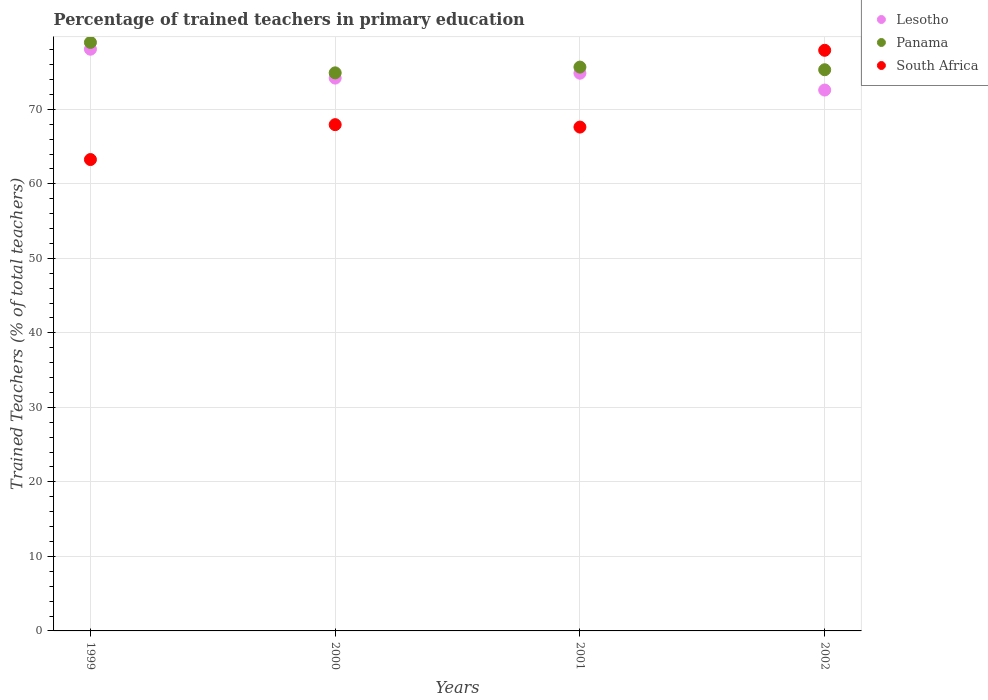What is the percentage of trained teachers in Lesotho in 2000?
Make the answer very short. 74.19. Across all years, what is the maximum percentage of trained teachers in South Africa?
Keep it short and to the point. 77.92. Across all years, what is the minimum percentage of trained teachers in Panama?
Keep it short and to the point. 74.89. In which year was the percentage of trained teachers in Panama maximum?
Offer a very short reply. 1999. In which year was the percentage of trained teachers in Lesotho minimum?
Give a very brief answer. 2002. What is the total percentage of trained teachers in Lesotho in the graph?
Your answer should be very brief. 299.69. What is the difference between the percentage of trained teachers in Lesotho in 2000 and that in 2001?
Your answer should be compact. -0.66. What is the difference between the percentage of trained teachers in South Africa in 2002 and the percentage of trained teachers in Panama in 2000?
Offer a terse response. 3.03. What is the average percentage of trained teachers in Lesotho per year?
Ensure brevity in your answer.  74.92. In the year 2000, what is the difference between the percentage of trained teachers in Lesotho and percentage of trained teachers in Panama?
Offer a very short reply. -0.7. What is the ratio of the percentage of trained teachers in Lesotho in 2001 to that in 2002?
Ensure brevity in your answer.  1.03. What is the difference between the highest and the second highest percentage of trained teachers in South Africa?
Your answer should be compact. 9.98. What is the difference between the highest and the lowest percentage of trained teachers in Lesotho?
Your answer should be very brief. 5.48. In how many years, is the percentage of trained teachers in Lesotho greater than the average percentage of trained teachers in Lesotho taken over all years?
Offer a very short reply. 1. Does the percentage of trained teachers in Panama monotonically increase over the years?
Make the answer very short. No. Is the percentage of trained teachers in Lesotho strictly greater than the percentage of trained teachers in Panama over the years?
Your answer should be compact. No. Is the percentage of trained teachers in South Africa strictly less than the percentage of trained teachers in Panama over the years?
Your answer should be very brief. No. How many years are there in the graph?
Offer a terse response. 4. What is the difference between two consecutive major ticks on the Y-axis?
Your answer should be compact. 10. Does the graph contain any zero values?
Offer a terse response. No. What is the title of the graph?
Your answer should be compact. Percentage of trained teachers in primary education. Does "Italy" appear as one of the legend labels in the graph?
Offer a very short reply. No. What is the label or title of the X-axis?
Offer a very short reply. Years. What is the label or title of the Y-axis?
Offer a very short reply. Trained Teachers (% of total teachers). What is the Trained Teachers (% of total teachers) of Lesotho in 1999?
Give a very brief answer. 78.07. What is the Trained Teachers (% of total teachers) of Panama in 1999?
Your answer should be compact. 78.98. What is the Trained Teachers (% of total teachers) of South Africa in 1999?
Your answer should be very brief. 63.26. What is the Trained Teachers (% of total teachers) of Lesotho in 2000?
Provide a succinct answer. 74.19. What is the Trained Teachers (% of total teachers) in Panama in 2000?
Your response must be concise. 74.89. What is the Trained Teachers (% of total teachers) of South Africa in 2000?
Make the answer very short. 67.94. What is the Trained Teachers (% of total teachers) of Lesotho in 2001?
Make the answer very short. 74.85. What is the Trained Teachers (% of total teachers) of Panama in 2001?
Give a very brief answer. 75.67. What is the Trained Teachers (% of total teachers) of South Africa in 2001?
Give a very brief answer. 67.62. What is the Trained Teachers (% of total teachers) of Lesotho in 2002?
Keep it short and to the point. 72.59. What is the Trained Teachers (% of total teachers) of Panama in 2002?
Ensure brevity in your answer.  75.31. What is the Trained Teachers (% of total teachers) in South Africa in 2002?
Provide a succinct answer. 77.92. Across all years, what is the maximum Trained Teachers (% of total teachers) in Lesotho?
Provide a short and direct response. 78.07. Across all years, what is the maximum Trained Teachers (% of total teachers) of Panama?
Provide a short and direct response. 78.98. Across all years, what is the maximum Trained Teachers (% of total teachers) of South Africa?
Offer a very short reply. 77.92. Across all years, what is the minimum Trained Teachers (% of total teachers) of Lesotho?
Offer a very short reply. 72.59. Across all years, what is the minimum Trained Teachers (% of total teachers) in Panama?
Your response must be concise. 74.89. Across all years, what is the minimum Trained Teachers (% of total teachers) of South Africa?
Keep it short and to the point. 63.26. What is the total Trained Teachers (% of total teachers) of Lesotho in the graph?
Keep it short and to the point. 299.69. What is the total Trained Teachers (% of total teachers) in Panama in the graph?
Make the answer very short. 304.85. What is the total Trained Teachers (% of total teachers) of South Africa in the graph?
Offer a very short reply. 276.74. What is the difference between the Trained Teachers (% of total teachers) in Lesotho in 1999 and that in 2000?
Offer a terse response. 3.88. What is the difference between the Trained Teachers (% of total teachers) of Panama in 1999 and that in 2000?
Offer a terse response. 4.08. What is the difference between the Trained Teachers (% of total teachers) of South Africa in 1999 and that in 2000?
Give a very brief answer. -4.68. What is the difference between the Trained Teachers (% of total teachers) of Lesotho in 1999 and that in 2001?
Ensure brevity in your answer.  3.22. What is the difference between the Trained Teachers (% of total teachers) of Panama in 1999 and that in 2001?
Ensure brevity in your answer.  3.31. What is the difference between the Trained Teachers (% of total teachers) in South Africa in 1999 and that in 2001?
Make the answer very short. -4.36. What is the difference between the Trained Teachers (% of total teachers) in Lesotho in 1999 and that in 2002?
Keep it short and to the point. 5.48. What is the difference between the Trained Teachers (% of total teachers) in Panama in 1999 and that in 2002?
Your answer should be very brief. 3.66. What is the difference between the Trained Teachers (% of total teachers) in South Africa in 1999 and that in 2002?
Make the answer very short. -14.66. What is the difference between the Trained Teachers (% of total teachers) of Lesotho in 2000 and that in 2001?
Provide a succinct answer. -0.66. What is the difference between the Trained Teachers (% of total teachers) of Panama in 2000 and that in 2001?
Ensure brevity in your answer.  -0.77. What is the difference between the Trained Teachers (% of total teachers) of South Africa in 2000 and that in 2001?
Ensure brevity in your answer.  0.33. What is the difference between the Trained Teachers (% of total teachers) of Lesotho in 2000 and that in 2002?
Your answer should be compact. 1.6. What is the difference between the Trained Teachers (% of total teachers) in Panama in 2000 and that in 2002?
Offer a very short reply. -0.42. What is the difference between the Trained Teachers (% of total teachers) of South Africa in 2000 and that in 2002?
Keep it short and to the point. -9.98. What is the difference between the Trained Teachers (% of total teachers) of Lesotho in 2001 and that in 2002?
Provide a succinct answer. 2.26. What is the difference between the Trained Teachers (% of total teachers) of Panama in 2001 and that in 2002?
Give a very brief answer. 0.36. What is the difference between the Trained Teachers (% of total teachers) of South Africa in 2001 and that in 2002?
Give a very brief answer. -10.31. What is the difference between the Trained Teachers (% of total teachers) in Lesotho in 1999 and the Trained Teachers (% of total teachers) in Panama in 2000?
Keep it short and to the point. 3.17. What is the difference between the Trained Teachers (% of total teachers) in Lesotho in 1999 and the Trained Teachers (% of total teachers) in South Africa in 2000?
Your response must be concise. 10.12. What is the difference between the Trained Teachers (% of total teachers) in Panama in 1999 and the Trained Teachers (% of total teachers) in South Africa in 2000?
Keep it short and to the point. 11.03. What is the difference between the Trained Teachers (% of total teachers) of Lesotho in 1999 and the Trained Teachers (% of total teachers) of Panama in 2001?
Offer a terse response. 2.4. What is the difference between the Trained Teachers (% of total teachers) in Lesotho in 1999 and the Trained Teachers (% of total teachers) in South Africa in 2001?
Give a very brief answer. 10.45. What is the difference between the Trained Teachers (% of total teachers) in Panama in 1999 and the Trained Teachers (% of total teachers) in South Africa in 2001?
Provide a succinct answer. 11.36. What is the difference between the Trained Teachers (% of total teachers) in Lesotho in 1999 and the Trained Teachers (% of total teachers) in Panama in 2002?
Provide a succinct answer. 2.75. What is the difference between the Trained Teachers (% of total teachers) of Lesotho in 1999 and the Trained Teachers (% of total teachers) of South Africa in 2002?
Keep it short and to the point. 0.15. What is the difference between the Trained Teachers (% of total teachers) of Panama in 1999 and the Trained Teachers (% of total teachers) of South Africa in 2002?
Provide a short and direct response. 1.06. What is the difference between the Trained Teachers (% of total teachers) in Lesotho in 2000 and the Trained Teachers (% of total teachers) in Panama in 2001?
Provide a short and direct response. -1.48. What is the difference between the Trained Teachers (% of total teachers) of Lesotho in 2000 and the Trained Teachers (% of total teachers) of South Africa in 2001?
Offer a terse response. 6.57. What is the difference between the Trained Teachers (% of total teachers) of Panama in 2000 and the Trained Teachers (% of total teachers) of South Africa in 2001?
Give a very brief answer. 7.28. What is the difference between the Trained Teachers (% of total teachers) of Lesotho in 2000 and the Trained Teachers (% of total teachers) of Panama in 2002?
Ensure brevity in your answer.  -1.12. What is the difference between the Trained Teachers (% of total teachers) of Lesotho in 2000 and the Trained Teachers (% of total teachers) of South Africa in 2002?
Make the answer very short. -3.73. What is the difference between the Trained Teachers (% of total teachers) in Panama in 2000 and the Trained Teachers (% of total teachers) in South Africa in 2002?
Your answer should be compact. -3.03. What is the difference between the Trained Teachers (% of total teachers) of Lesotho in 2001 and the Trained Teachers (% of total teachers) of Panama in 2002?
Your answer should be compact. -0.47. What is the difference between the Trained Teachers (% of total teachers) of Lesotho in 2001 and the Trained Teachers (% of total teachers) of South Africa in 2002?
Provide a succinct answer. -3.08. What is the difference between the Trained Teachers (% of total teachers) of Panama in 2001 and the Trained Teachers (% of total teachers) of South Africa in 2002?
Offer a terse response. -2.25. What is the average Trained Teachers (% of total teachers) in Lesotho per year?
Ensure brevity in your answer.  74.92. What is the average Trained Teachers (% of total teachers) in Panama per year?
Your answer should be compact. 76.21. What is the average Trained Teachers (% of total teachers) of South Africa per year?
Make the answer very short. 69.18. In the year 1999, what is the difference between the Trained Teachers (% of total teachers) in Lesotho and Trained Teachers (% of total teachers) in Panama?
Offer a terse response. -0.91. In the year 1999, what is the difference between the Trained Teachers (% of total teachers) in Lesotho and Trained Teachers (% of total teachers) in South Africa?
Offer a very short reply. 14.81. In the year 1999, what is the difference between the Trained Teachers (% of total teachers) of Panama and Trained Teachers (% of total teachers) of South Africa?
Your response must be concise. 15.72. In the year 2000, what is the difference between the Trained Teachers (% of total teachers) in Lesotho and Trained Teachers (% of total teachers) in Panama?
Keep it short and to the point. -0.7. In the year 2000, what is the difference between the Trained Teachers (% of total teachers) in Lesotho and Trained Teachers (% of total teachers) in South Africa?
Provide a succinct answer. 6.25. In the year 2000, what is the difference between the Trained Teachers (% of total teachers) of Panama and Trained Teachers (% of total teachers) of South Africa?
Keep it short and to the point. 6.95. In the year 2001, what is the difference between the Trained Teachers (% of total teachers) of Lesotho and Trained Teachers (% of total teachers) of Panama?
Provide a short and direct response. -0.82. In the year 2001, what is the difference between the Trained Teachers (% of total teachers) in Lesotho and Trained Teachers (% of total teachers) in South Africa?
Your response must be concise. 7.23. In the year 2001, what is the difference between the Trained Teachers (% of total teachers) in Panama and Trained Teachers (% of total teachers) in South Africa?
Offer a very short reply. 8.05. In the year 2002, what is the difference between the Trained Teachers (% of total teachers) of Lesotho and Trained Teachers (% of total teachers) of Panama?
Ensure brevity in your answer.  -2.73. In the year 2002, what is the difference between the Trained Teachers (% of total teachers) in Lesotho and Trained Teachers (% of total teachers) in South Africa?
Give a very brief answer. -5.34. In the year 2002, what is the difference between the Trained Teachers (% of total teachers) in Panama and Trained Teachers (% of total teachers) in South Africa?
Provide a succinct answer. -2.61. What is the ratio of the Trained Teachers (% of total teachers) in Lesotho in 1999 to that in 2000?
Provide a succinct answer. 1.05. What is the ratio of the Trained Teachers (% of total teachers) in Panama in 1999 to that in 2000?
Ensure brevity in your answer.  1.05. What is the ratio of the Trained Teachers (% of total teachers) in South Africa in 1999 to that in 2000?
Your response must be concise. 0.93. What is the ratio of the Trained Teachers (% of total teachers) in Lesotho in 1999 to that in 2001?
Ensure brevity in your answer.  1.04. What is the ratio of the Trained Teachers (% of total teachers) in Panama in 1999 to that in 2001?
Provide a short and direct response. 1.04. What is the ratio of the Trained Teachers (% of total teachers) of South Africa in 1999 to that in 2001?
Your answer should be very brief. 0.94. What is the ratio of the Trained Teachers (% of total teachers) in Lesotho in 1999 to that in 2002?
Give a very brief answer. 1.08. What is the ratio of the Trained Teachers (% of total teachers) of Panama in 1999 to that in 2002?
Ensure brevity in your answer.  1.05. What is the ratio of the Trained Teachers (% of total teachers) in South Africa in 1999 to that in 2002?
Your response must be concise. 0.81. What is the ratio of the Trained Teachers (% of total teachers) in Lesotho in 2000 to that in 2002?
Provide a succinct answer. 1.02. What is the ratio of the Trained Teachers (% of total teachers) of Panama in 2000 to that in 2002?
Make the answer very short. 0.99. What is the ratio of the Trained Teachers (% of total teachers) in South Africa in 2000 to that in 2002?
Offer a terse response. 0.87. What is the ratio of the Trained Teachers (% of total teachers) in Lesotho in 2001 to that in 2002?
Provide a succinct answer. 1.03. What is the ratio of the Trained Teachers (% of total teachers) of South Africa in 2001 to that in 2002?
Provide a short and direct response. 0.87. What is the difference between the highest and the second highest Trained Teachers (% of total teachers) of Lesotho?
Provide a succinct answer. 3.22. What is the difference between the highest and the second highest Trained Teachers (% of total teachers) in Panama?
Offer a terse response. 3.31. What is the difference between the highest and the second highest Trained Teachers (% of total teachers) in South Africa?
Ensure brevity in your answer.  9.98. What is the difference between the highest and the lowest Trained Teachers (% of total teachers) in Lesotho?
Give a very brief answer. 5.48. What is the difference between the highest and the lowest Trained Teachers (% of total teachers) in Panama?
Your answer should be very brief. 4.08. What is the difference between the highest and the lowest Trained Teachers (% of total teachers) in South Africa?
Make the answer very short. 14.66. 